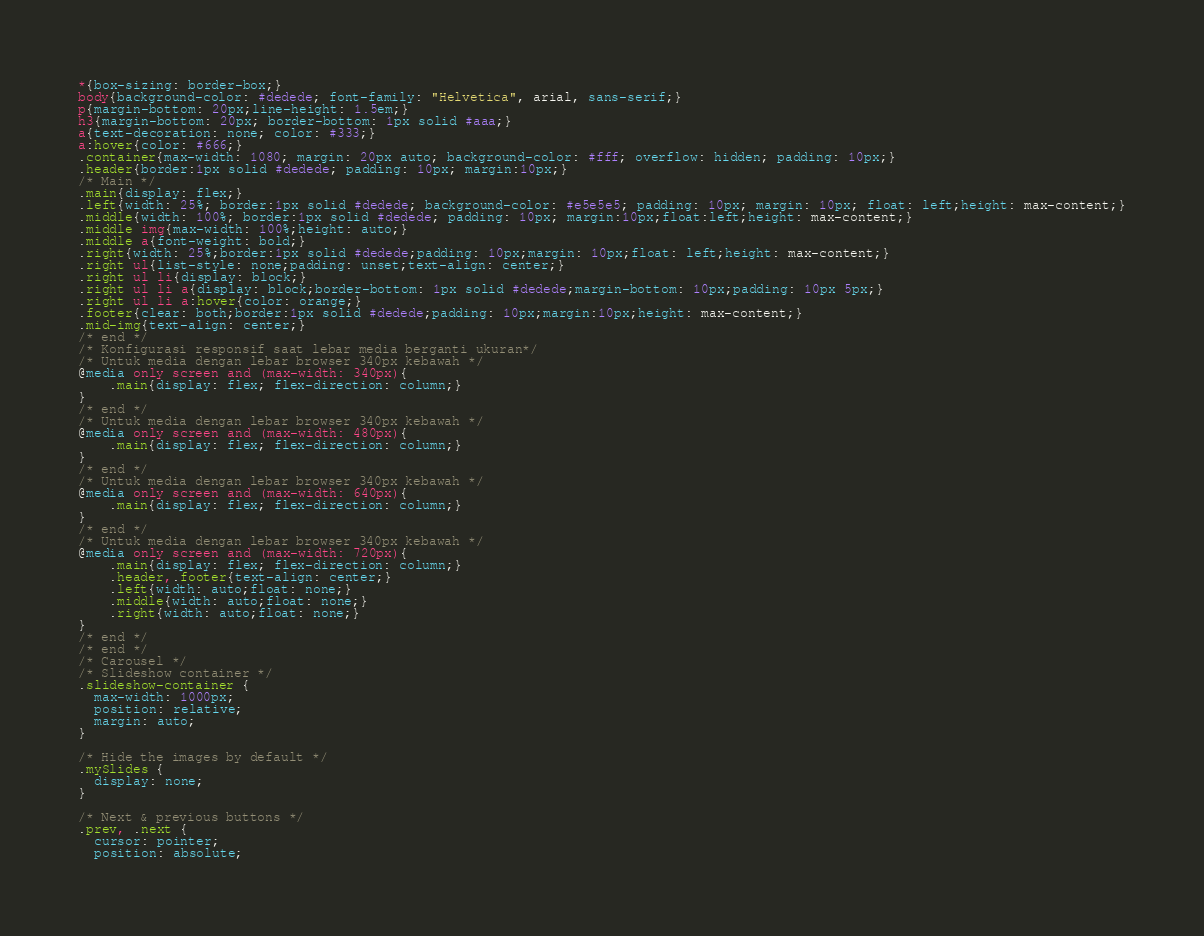Convert code to text. <code><loc_0><loc_0><loc_500><loc_500><_CSS_>*{box-sizing: border-box;}
body{background-color: #dedede; font-family: "Helvetica", arial, sans-serif;}
p{margin-bottom: 20px;line-height: 1.5em;}
h3{margin-bottom: 20px; border-bottom: 1px solid #aaa;}
a{text-decoration: none; color: #333;}
a:hover{color: #666;}
.container{max-width: 1080; margin: 20px auto; background-color: #fff; overflow: hidden; padding: 10px;}
.header{border:1px solid #dedede; padding: 10px; margin:10px;}
/* Main */
.main{display: flex;}
.left{width: 25%; border:1px solid #dedede; background-color: #e5e5e5; padding: 10px; margin: 10px; float: left;height: max-content;}
.middle{width: 100%; border:1px solid #dedede; padding: 10px; margin:10px;float:left;height: max-content;}
.middle img{max-width: 100%;height: auto;}
.middle a{font-weight: bold;}
.right{width: 25%;border:1px solid #dedede;padding: 10px;margin: 10px;float: left;height: max-content;}
.right ul{list-style: none;padding: unset;text-align: center;}
.right ul li{display: block;}
.right ul li a{display: block;border-bottom: 1px solid #dedede;margin-bottom: 10px;padding: 10px 5px;}
.right ul li a:hover{color: orange;}
.footer{clear: both;border:1px solid #dedede;padding: 10px;margin:10px;height: max-content;}
.mid-img{text-align: center;}
/* end */
/* Konfigurasi responsif saat lebar media berganti ukuran*/
/* Untuk media dengan lebar browser 340px kebawah */
@media only screen and (max-width: 340px){
	.main{display: flex; flex-direction: column;}
}
/* end */
/* Untuk media dengan lebar browser 340px kebawah */
@media only screen and (max-width: 480px){
	.main{display: flex; flex-direction: column;}
}
/* end */
/* Untuk media dengan lebar browser 340px kebawah */
@media only screen and (max-width: 640px){
	.main{display: flex; flex-direction: column;}
}
/* end */
/* Untuk media dengan lebar browser 340px kebawah */
@media only screen and (max-width: 720px){
	.main{display: flex; flex-direction: column;}
	.header,.footer{text-align: center;}
	.left{width: auto;float: none;}
	.middle{width: auto;float: none;}
	.right{width: auto;float: none;}
}
/* end */
/* end */
/* Carousel */
/* Slideshow container */
.slideshow-container {
  max-width: 1000px;
  position: relative;
  margin: auto;
}

/* Hide the images by default */
.mySlides {
  display: none;
}

/* Next & previous buttons */
.prev, .next {
  cursor: pointer;
  position: absolute;</code> 